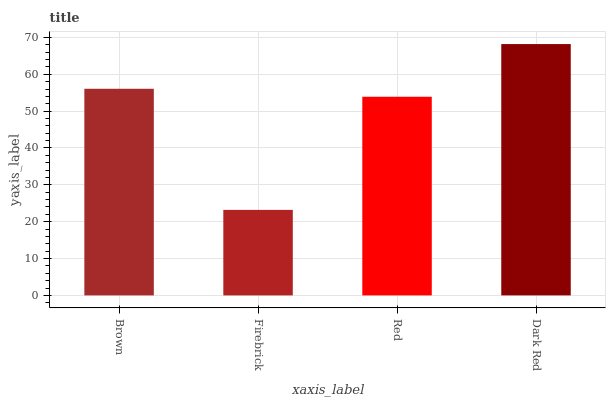Is Firebrick the minimum?
Answer yes or no. Yes. Is Dark Red the maximum?
Answer yes or no. Yes. Is Red the minimum?
Answer yes or no. No. Is Red the maximum?
Answer yes or no. No. Is Red greater than Firebrick?
Answer yes or no. Yes. Is Firebrick less than Red?
Answer yes or no. Yes. Is Firebrick greater than Red?
Answer yes or no. No. Is Red less than Firebrick?
Answer yes or no. No. Is Brown the high median?
Answer yes or no. Yes. Is Red the low median?
Answer yes or no. Yes. Is Red the high median?
Answer yes or no. No. Is Brown the low median?
Answer yes or no. No. 